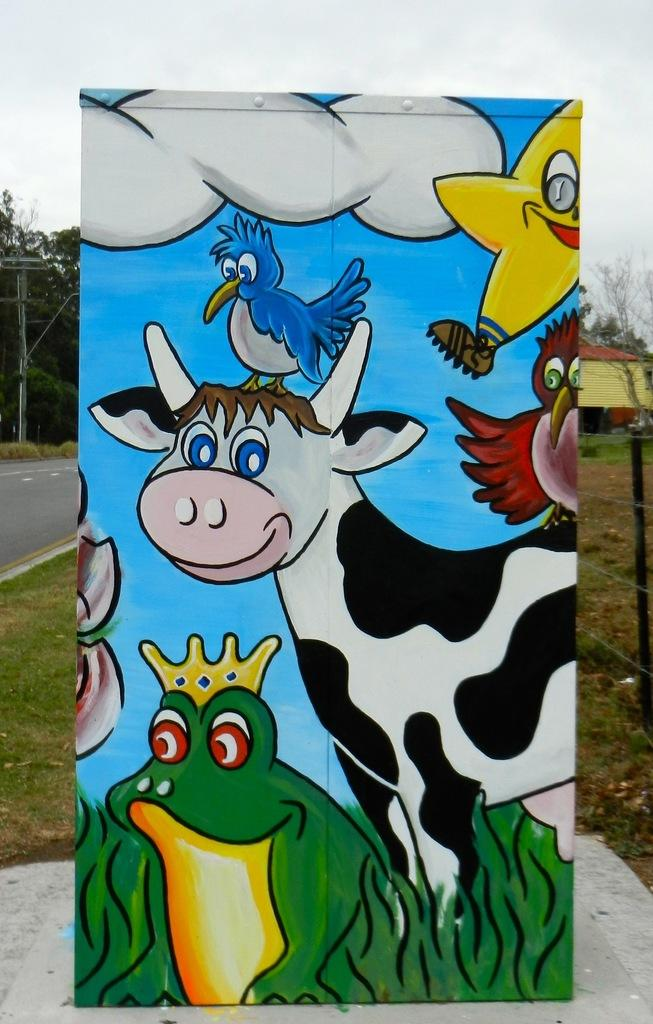What is the main subject of the image? There is a board with a painting in the center of the image. What can be seen in the background of the image? There is a road, trees, a house, and grass in the background of the image. How many fish are swimming in the painting on the board? There is no information about fish in the painting on the board, as the facts provided do not mention any fish. 